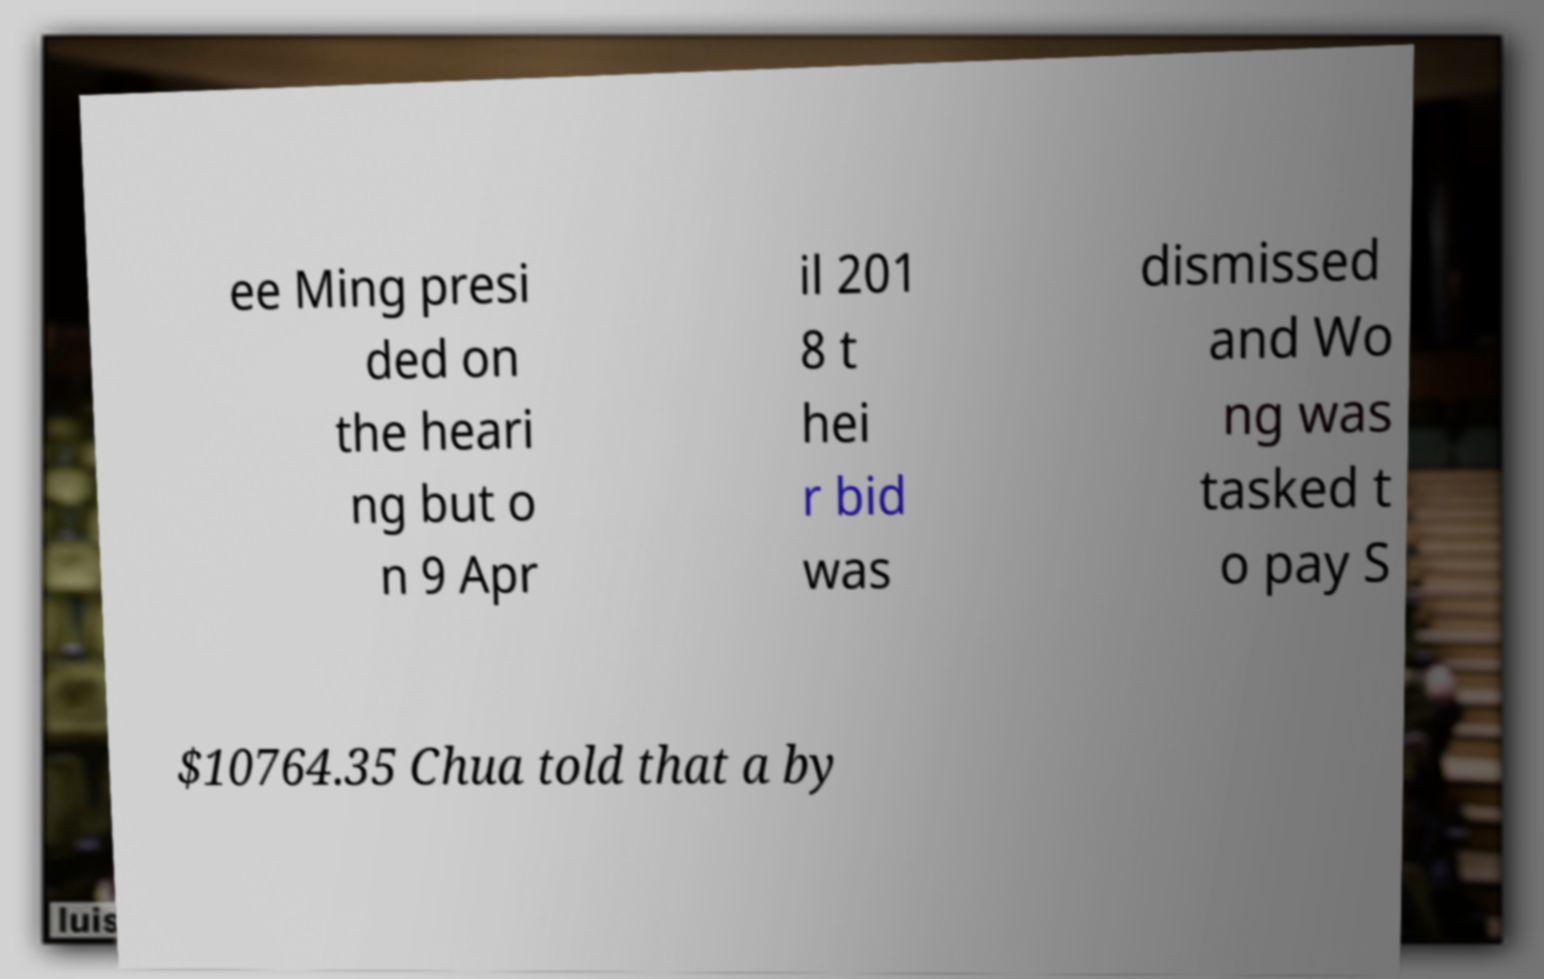Can you accurately transcribe the text from the provided image for me? ee Ming presi ded on the heari ng but o n 9 Apr il 201 8 t hei r bid was dismissed and Wo ng was tasked t o pay S $10764.35 Chua told that a by 